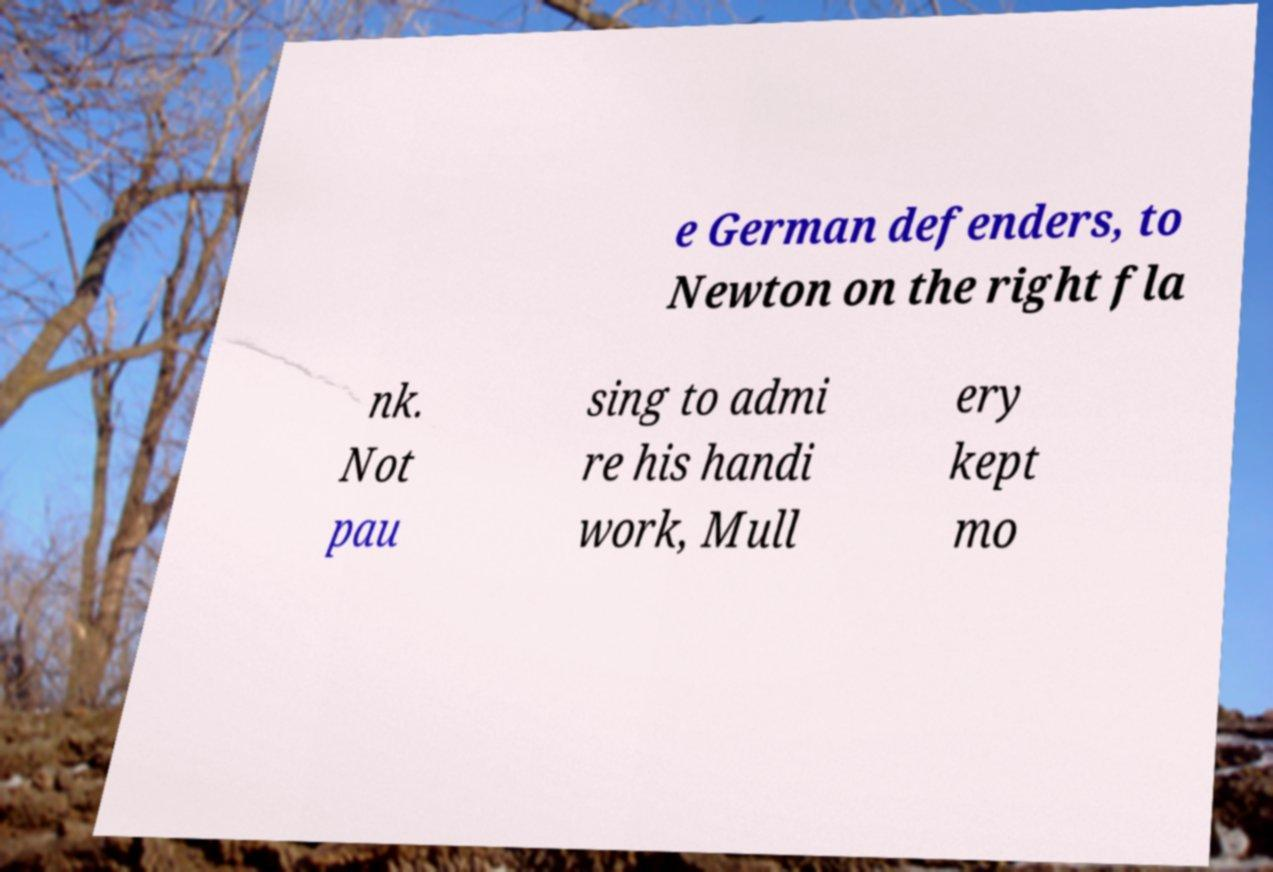There's text embedded in this image that I need extracted. Can you transcribe it verbatim? e German defenders, to Newton on the right fla nk. Not pau sing to admi re his handi work, Mull ery kept mo 